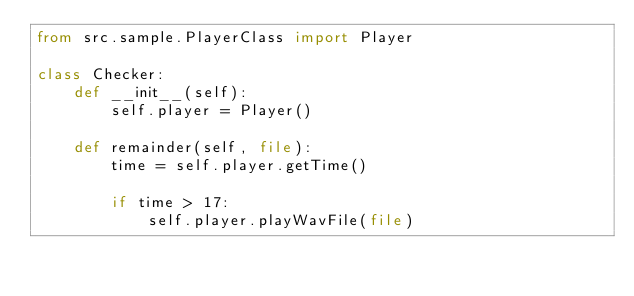<code> <loc_0><loc_0><loc_500><loc_500><_Python_>from src.sample.PlayerClass import Player

class Checker:
    def __init__(self):
        self.player = Player()
    
    def remainder(self, file):
        time = self.player.getTime()

        if time > 17:
            self.player.playWavFile(file)</code> 